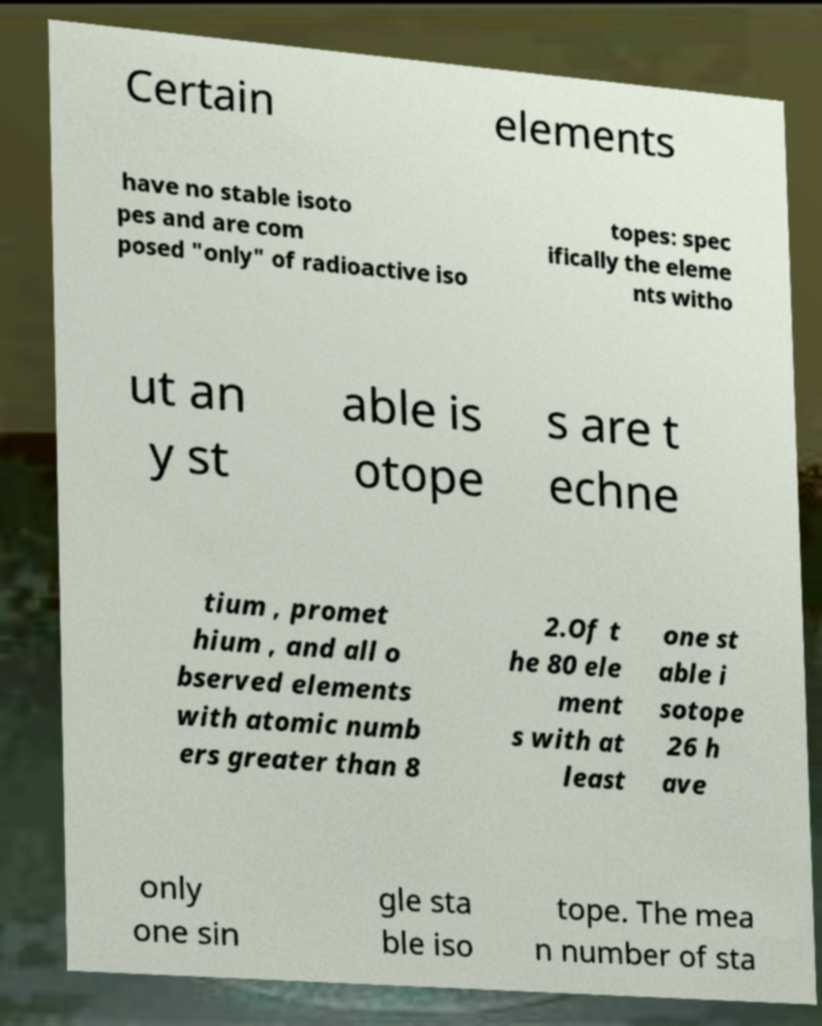Could you assist in decoding the text presented in this image and type it out clearly? Certain elements have no stable isoto pes and are com posed "only" of radioactive iso topes: spec ifically the eleme nts witho ut an y st able is otope s are t echne tium , promet hium , and all o bserved elements with atomic numb ers greater than 8 2.Of t he 80 ele ment s with at least one st able i sotope 26 h ave only one sin gle sta ble iso tope. The mea n number of sta 